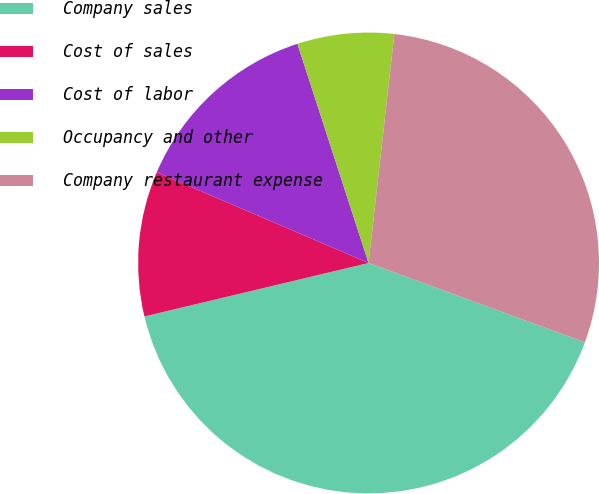Convert chart. <chart><loc_0><loc_0><loc_500><loc_500><pie_chart><fcel>Company sales<fcel>Cost of sales<fcel>Cost of labor<fcel>Occupancy and other<fcel>Company restaurant expense<nl><fcel>40.68%<fcel>10.17%<fcel>13.56%<fcel>6.78%<fcel>28.81%<nl></chart> 